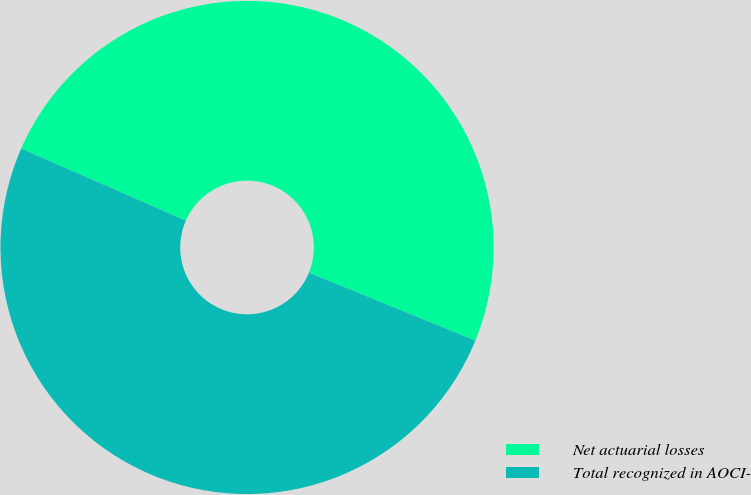<chart> <loc_0><loc_0><loc_500><loc_500><pie_chart><fcel>Net actuarial losses<fcel>Total recognized in AOCI-<nl><fcel>49.59%<fcel>50.41%<nl></chart> 